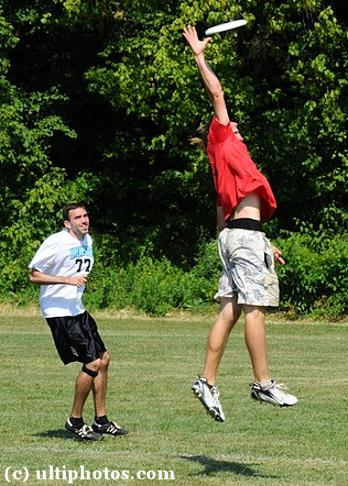Question: what is cast?
Choices:
A. Shadow.
B. Leading role.
C. Quote in stone.
D. Fishing line.
Answer with the letter. Answer: A Question: what is he doing?
Choices:
A. Sleeping.
B. Eating.
C. Jumping.
D. Skateboarding.
Answer with the letter. Answer: C Question: why is he jumping?
Choices:
A. Over rope.
B. Skateboard trick.
C. Playing.
D. To get on boat.
Answer with the letter. Answer: C Question: how is the man?
Choices:
A. Horizontal.
B. Old.
C. In motion.
D. Tired.
Answer with the letter. Answer: C 